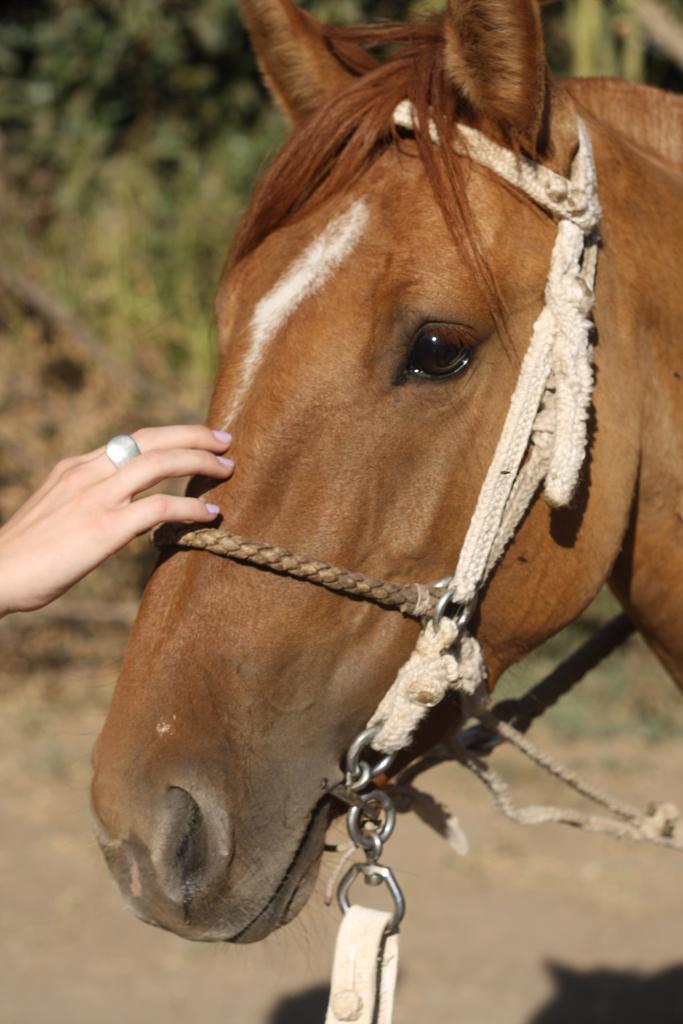Describe this image in one or two sentences. In this picture, there is a horse towards the right. It is tied with the ropes and belts. Towards the left, there is a hand. To the finger there is a ring. In the background, there are trees. 